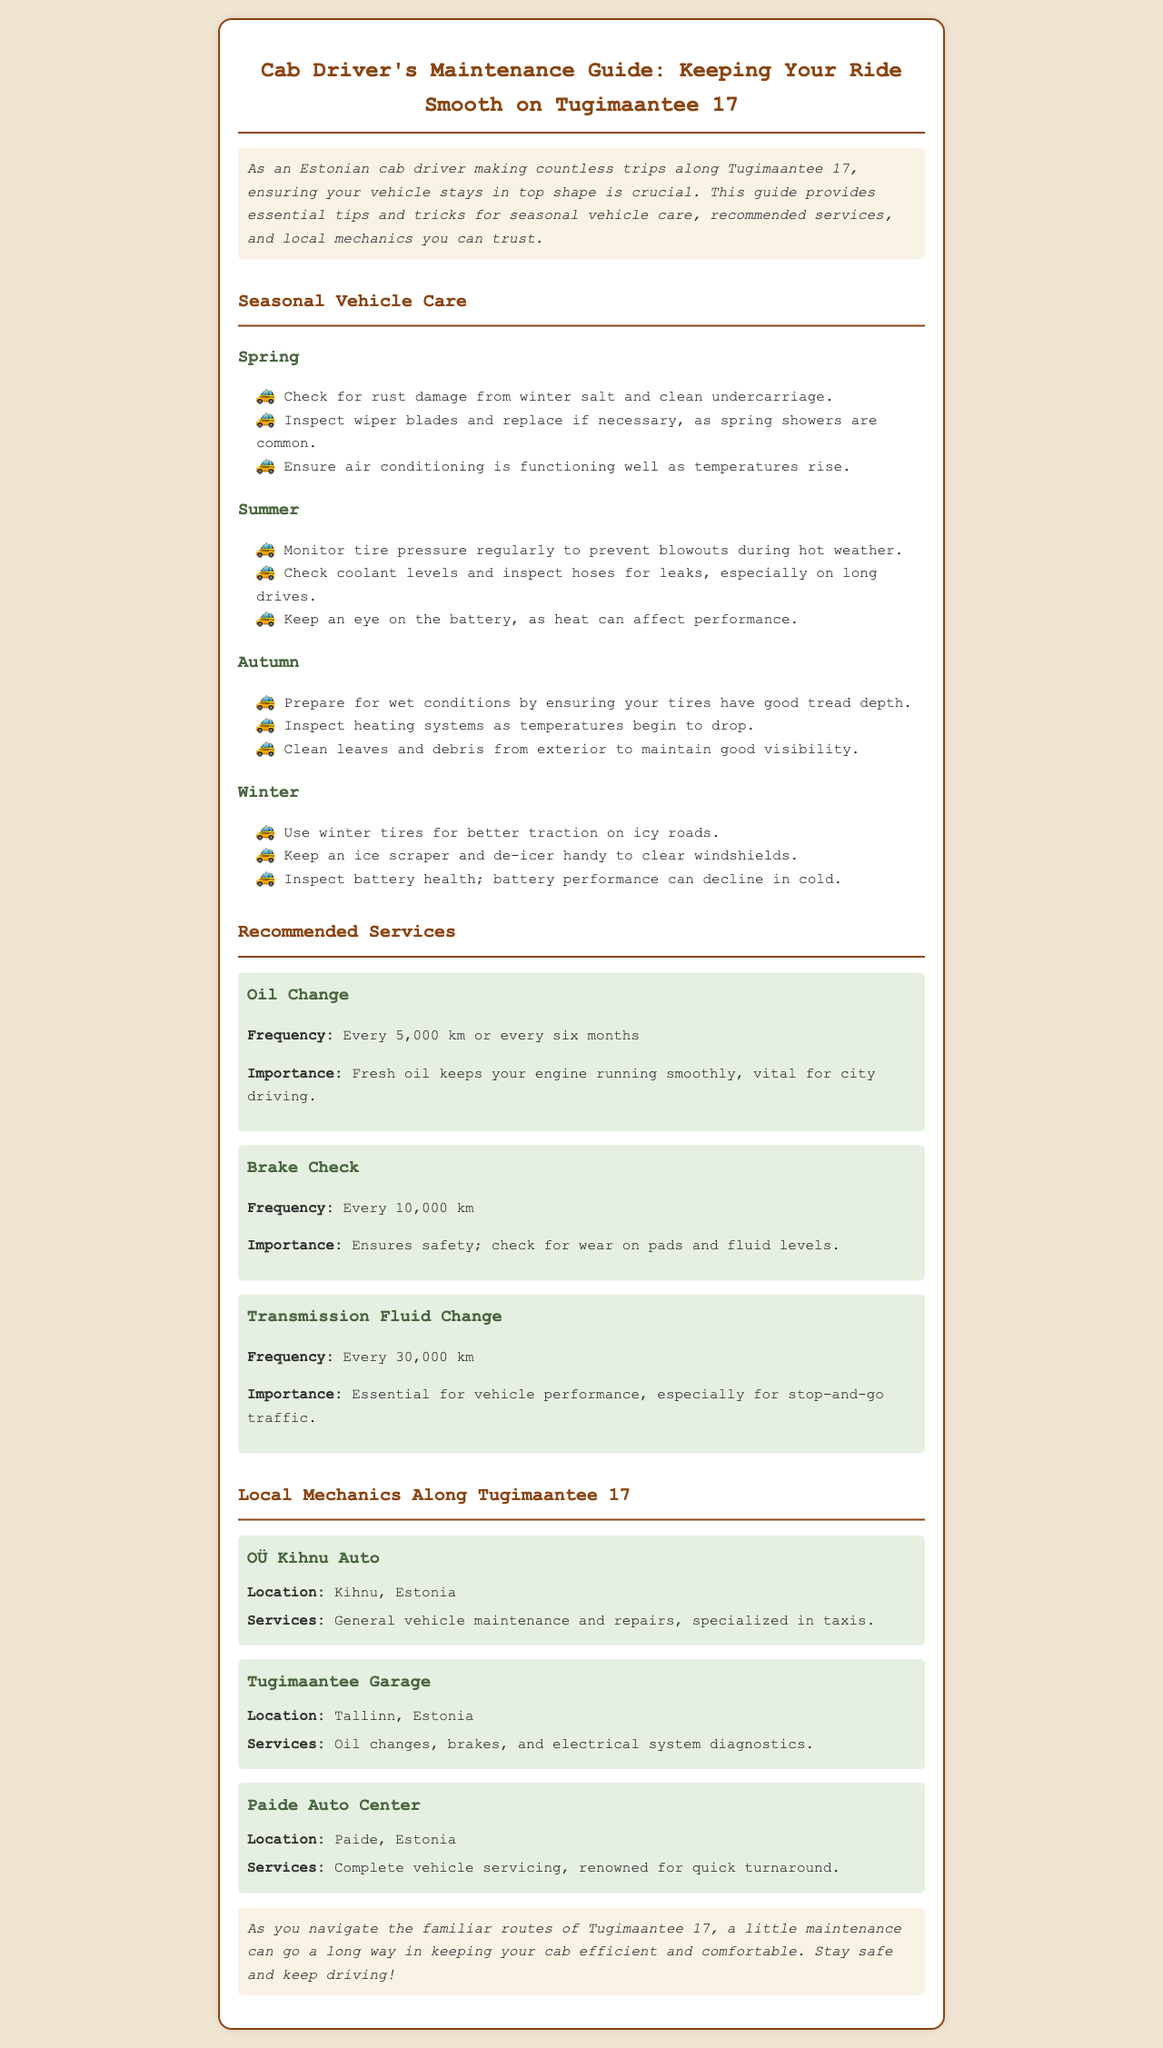What is the title of the newsletter? The title of the newsletter clearly states the purpose of the document, which is about maintenance for cab drivers.
Answer: Cab Driver's Maintenance Guide: Keeping Your Ride Smooth on Tugimaantee 17 What should be checked in spring for vehicle care? The document lists specific vehicle care tasks organized by season, including a check for rust damage in spring.
Answer: Check for rust damage from winter salt and clean undercarriage How often should oil changes be done? The frequency of recommended services is specified in the document for various vehicle maintenance tasks.
Answer: Every 5,000 km or every six months Which garage is located in Tallinn? The document provides names and locations of local mechanics along Tugimaantee 17, including their city names.
Answer: Tugimaantee Garage What is one of the recommended services for safety? Safety-related maintenance tasks are highlighted, especially regarding break checks.
Answer: Brake Check Why is monitoring tire pressure important in summer? The document explains reasons behind the recommended maintenance tasks, particularly due to weather conditions.
Answer: To prevent blowouts during hot weather What style is the newsletter written in? The document’s content and structure indicate it aims to inform cab drivers specifically, which is a characteristic of newsletters.
Answer: Informative What does the conclusion emphasize? The conclusion summarizes the main message of the newsletter in context to the routes cab drivers take.
Answer: A little maintenance can go a long way in keeping your cab efficient and comfortable 